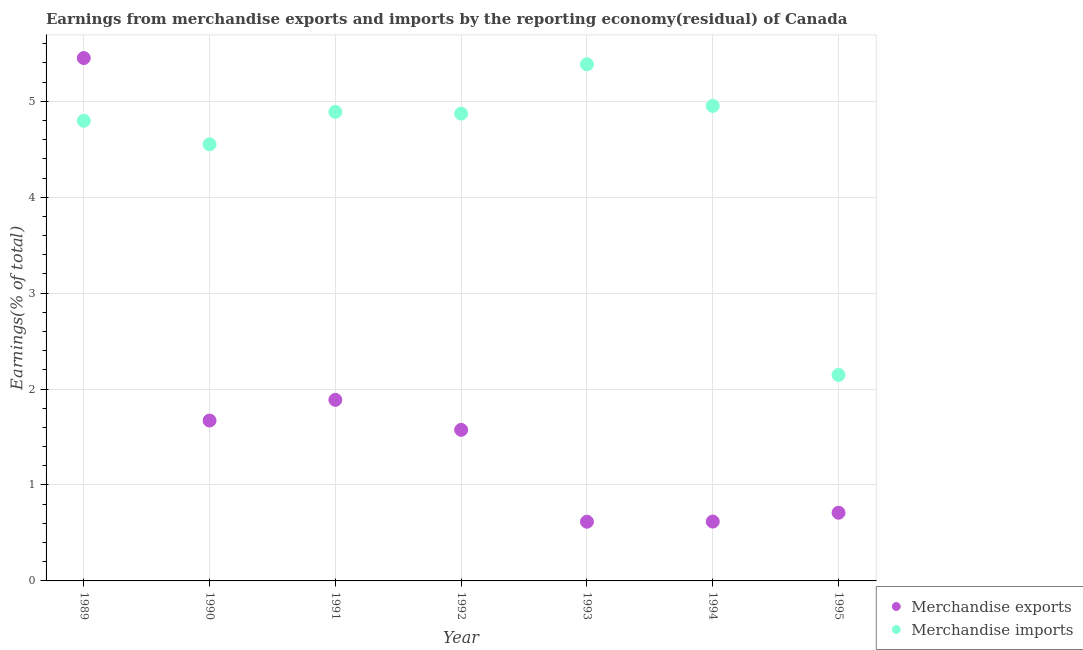How many different coloured dotlines are there?
Keep it short and to the point. 2. What is the earnings from merchandise exports in 1991?
Make the answer very short. 1.89. Across all years, what is the maximum earnings from merchandise exports?
Provide a short and direct response. 5.45. Across all years, what is the minimum earnings from merchandise imports?
Your response must be concise. 2.15. In which year was the earnings from merchandise imports maximum?
Provide a succinct answer. 1993. What is the total earnings from merchandise exports in the graph?
Ensure brevity in your answer.  12.53. What is the difference between the earnings from merchandise imports in 1991 and that in 1994?
Ensure brevity in your answer.  -0.06. What is the difference between the earnings from merchandise imports in 1990 and the earnings from merchandise exports in 1991?
Offer a very short reply. 2.66. What is the average earnings from merchandise exports per year?
Offer a very short reply. 1.79. In the year 1993, what is the difference between the earnings from merchandise imports and earnings from merchandise exports?
Your answer should be very brief. 4.77. What is the ratio of the earnings from merchandise exports in 1989 to that in 1990?
Give a very brief answer. 3.26. Is the earnings from merchandise imports in 1991 less than that in 1993?
Ensure brevity in your answer.  Yes. Is the difference between the earnings from merchandise exports in 1989 and 1995 greater than the difference between the earnings from merchandise imports in 1989 and 1995?
Provide a succinct answer. Yes. What is the difference between the highest and the second highest earnings from merchandise exports?
Ensure brevity in your answer.  3.56. What is the difference between the highest and the lowest earnings from merchandise imports?
Your answer should be compact. 3.24. Is the sum of the earnings from merchandise exports in 1992 and 1993 greater than the maximum earnings from merchandise imports across all years?
Provide a short and direct response. No. Is the earnings from merchandise exports strictly greater than the earnings from merchandise imports over the years?
Ensure brevity in your answer.  No. How many dotlines are there?
Provide a short and direct response. 2. What is the difference between two consecutive major ticks on the Y-axis?
Make the answer very short. 1. Are the values on the major ticks of Y-axis written in scientific E-notation?
Give a very brief answer. No. How many legend labels are there?
Offer a terse response. 2. What is the title of the graph?
Give a very brief answer. Earnings from merchandise exports and imports by the reporting economy(residual) of Canada. What is the label or title of the X-axis?
Offer a very short reply. Year. What is the label or title of the Y-axis?
Offer a terse response. Earnings(% of total). What is the Earnings(% of total) of Merchandise exports in 1989?
Keep it short and to the point. 5.45. What is the Earnings(% of total) in Merchandise imports in 1989?
Make the answer very short. 4.8. What is the Earnings(% of total) of Merchandise exports in 1990?
Your response must be concise. 1.67. What is the Earnings(% of total) in Merchandise imports in 1990?
Provide a succinct answer. 4.55. What is the Earnings(% of total) in Merchandise exports in 1991?
Offer a very short reply. 1.89. What is the Earnings(% of total) of Merchandise imports in 1991?
Offer a very short reply. 4.89. What is the Earnings(% of total) of Merchandise exports in 1992?
Your response must be concise. 1.57. What is the Earnings(% of total) of Merchandise imports in 1992?
Your answer should be very brief. 4.87. What is the Earnings(% of total) in Merchandise exports in 1993?
Your response must be concise. 0.62. What is the Earnings(% of total) of Merchandise imports in 1993?
Your answer should be very brief. 5.39. What is the Earnings(% of total) of Merchandise exports in 1994?
Provide a succinct answer. 0.62. What is the Earnings(% of total) in Merchandise imports in 1994?
Keep it short and to the point. 4.95. What is the Earnings(% of total) of Merchandise exports in 1995?
Your answer should be very brief. 0.71. What is the Earnings(% of total) in Merchandise imports in 1995?
Your answer should be compact. 2.15. Across all years, what is the maximum Earnings(% of total) in Merchandise exports?
Offer a very short reply. 5.45. Across all years, what is the maximum Earnings(% of total) of Merchandise imports?
Keep it short and to the point. 5.39. Across all years, what is the minimum Earnings(% of total) of Merchandise exports?
Offer a very short reply. 0.62. Across all years, what is the minimum Earnings(% of total) in Merchandise imports?
Provide a short and direct response. 2.15. What is the total Earnings(% of total) of Merchandise exports in the graph?
Give a very brief answer. 12.53. What is the total Earnings(% of total) in Merchandise imports in the graph?
Your answer should be compact. 31.59. What is the difference between the Earnings(% of total) of Merchandise exports in 1989 and that in 1990?
Provide a succinct answer. 3.78. What is the difference between the Earnings(% of total) of Merchandise imports in 1989 and that in 1990?
Make the answer very short. 0.25. What is the difference between the Earnings(% of total) in Merchandise exports in 1989 and that in 1991?
Give a very brief answer. 3.56. What is the difference between the Earnings(% of total) of Merchandise imports in 1989 and that in 1991?
Your answer should be compact. -0.09. What is the difference between the Earnings(% of total) in Merchandise exports in 1989 and that in 1992?
Offer a terse response. 3.88. What is the difference between the Earnings(% of total) of Merchandise imports in 1989 and that in 1992?
Offer a very short reply. -0.07. What is the difference between the Earnings(% of total) of Merchandise exports in 1989 and that in 1993?
Your response must be concise. 4.83. What is the difference between the Earnings(% of total) of Merchandise imports in 1989 and that in 1993?
Offer a terse response. -0.59. What is the difference between the Earnings(% of total) in Merchandise exports in 1989 and that in 1994?
Your response must be concise. 4.83. What is the difference between the Earnings(% of total) of Merchandise imports in 1989 and that in 1994?
Offer a terse response. -0.16. What is the difference between the Earnings(% of total) of Merchandise exports in 1989 and that in 1995?
Your answer should be very brief. 4.74. What is the difference between the Earnings(% of total) in Merchandise imports in 1989 and that in 1995?
Offer a terse response. 2.65. What is the difference between the Earnings(% of total) of Merchandise exports in 1990 and that in 1991?
Your answer should be compact. -0.22. What is the difference between the Earnings(% of total) of Merchandise imports in 1990 and that in 1991?
Your response must be concise. -0.34. What is the difference between the Earnings(% of total) in Merchandise exports in 1990 and that in 1992?
Keep it short and to the point. 0.1. What is the difference between the Earnings(% of total) in Merchandise imports in 1990 and that in 1992?
Provide a succinct answer. -0.32. What is the difference between the Earnings(% of total) of Merchandise exports in 1990 and that in 1993?
Your answer should be very brief. 1.05. What is the difference between the Earnings(% of total) of Merchandise imports in 1990 and that in 1993?
Your answer should be very brief. -0.83. What is the difference between the Earnings(% of total) in Merchandise exports in 1990 and that in 1994?
Offer a terse response. 1.05. What is the difference between the Earnings(% of total) of Merchandise imports in 1990 and that in 1994?
Your answer should be compact. -0.4. What is the difference between the Earnings(% of total) in Merchandise exports in 1990 and that in 1995?
Your answer should be compact. 0.96. What is the difference between the Earnings(% of total) in Merchandise imports in 1990 and that in 1995?
Your response must be concise. 2.4. What is the difference between the Earnings(% of total) in Merchandise exports in 1991 and that in 1992?
Offer a very short reply. 0.31. What is the difference between the Earnings(% of total) of Merchandise imports in 1991 and that in 1992?
Keep it short and to the point. 0.02. What is the difference between the Earnings(% of total) in Merchandise exports in 1991 and that in 1993?
Keep it short and to the point. 1.27. What is the difference between the Earnings(% of total) of Merchandise imports in 1991 and that in 1993?
Keep it short and to the point. -0.5. What is the difference between the Earnings(% of total) of Merchandise exports in 1991 and that in 1994?
Give a very brief answer. 1.27. What is the difference between the Earnings(% of total) of Merchandise imports in 1991 and that in 1994?
Your answer should be very brief. -0.06. What is the difference between the Earnings(% of total) in Merchandise exports in 1991 and that in 1995?
Give a very brief answer. 1.18. What is the difference between the Earnings(% of total) in Merchandise imports in 1991 and that in 1995?
Make the answer very short. 2.74. What is the difference between the Earnings(% of total) of Merchandise exports in 1992 and that in 1993?
Keep it short and to the point. 0.96. What is the difference between the Earnings(% of total) in Merchandise imports in 1992 and that in 1993?
Your answer should be very brief. -0.51. What is the difference between the Earnings(% of total) in Merchandise exports in 1992 and that in 1994?
Offer a very short reply. 0.96. What is the difference between the Earnings(% of total) of Merchandise imports in 1992 and that in 1994?
Keep it short and to the point. -0.08. What is the difference between the Earnings(% of total) in Merchandise exports in 1992 and that in 1995?
Give a very brief answer. 0.86. What is the difference between the Earnings(% of total) of Merchandise imports in 1992 and that in 1995?
Provide a short and direct response. 2.72. What is the difference between the Earnings(% of total) of Merchandise exports in 1993 and that in 1994?
Provide a succinct answer. -0. What is the difference between the Earnings(% of total) in Merchandise imports in 1993 and that in 1994?
Give a very brief answer. 0.43. What is the difference between the Earnings(% of total) in Merchandise exports in 1993 and that in 1995?
Your response must be concise. -0.09. What is the difference between the Earnings(% of total) in Merchandise imports in 1993 and that in 1995?
Provide a succinct answer. 3.24. What is the difference between the Earnings(% of total) of Merchandise exports in 1994 and that in 1995?
Your response must be concise. -0.09. What is the difference between the Earnings(% of total) of Merchandise imports in 1994 and that in 1995?
Your answer should be very brief. 2.8. What is the difference between the Earnings(% of total) in Merchandise exports in 1989 and the Earnings(% of total) in Merchandise imports in 1990?
Your answer should be compact. 0.9. What is the difference between the Earnings(% of total) of Merchandise exports in 1989 and the Earnings(% of total) of Merchandise imports in 1991?
Offer a terse response. 0.56. What is the difference between the Earnings(% of total) of Merchandise exports in 1989 and the Earnings(% of total) of Merchandise imports in 1992?
Provide a short and direct response. 0.58. What is the difference between the Earnings(% of total) in Merchandise exports in 1989 and the Earnings(% of total) in Merchandise imports in 1993?
Your answer should be very brief. 0.06. What is the difference between the Earnings(% of total) of Merchandise exports in 1989 and the Earnings(% of total) of Merchandise imports in 1994?
Ensure brevity in your answer.  0.5. What is the difference between the Earnings(% of total) in Merchandise exports in 1989 and the Earnings(% of total) in Merchandise imports in 1995?
Your response must be concise. 3.3. What is the difference between the Earnings(% of total) of Merchandise exports in 1990 and the Earnings(% of total) of Merchandise imports in 1991?
Make the answer very short. -3.22. What is the difference between the Earnings(% of total) in Merchandise exports in 1990 and the Earnings(% of total) in Merchandise imports in 1992?
Your response must be concise. -3.2. What is the difference between the Earnings(% of total) of Merchandise exports in 1990 and the Earnings(% of total) of Merchandise imports in 1993?
Provide a short and direct response. -3.71. What is the difference between the Earnings(% of total) of Merchandise exports in 1990 and the Earnings(% of total) of Merchandise imports in 1994?
Provide a short and direct response. -3.28. What is the difference between the Earnings(% of total) of Merchandise exports in 1990 and the Earnings(% of total) of Merchandise imports in 1995?
Provide a short and direct response. -0.48. What is the difference between the Earnings(% of total) of Merchandise exports in 1991 and the Earnings(% of total) of Merchandise imports in 1992?
Your answer should be very brief. -2.98. What is the difference between the Earnings(% of total) of Merchandise exports in 1991 and the Earnings(% of total) of Merchandise imports in 1993?
Provide a succinct answer. -3.5. What is the difference between the Earnings(% of total) of Merchandise exports in 1991 and the Earnings(% of total) of Merchandise imports in 1994?
Your answer should be very brief. -3.06. What is the difference between the Earnings(% of total) of Merchandise exports in 1991 and the Earnings(% of total) of Merchandise imports in 1995?
Your answer should be very brief. -0.26. What is the difference between the Earnings(% of total) of Merchandise exports in 1992 and the Earnings(% of total) of Merchandise imports in 1993?
Your answer should be compact. -3.81. What is the difference between the Earnings(% of total) in Merchandise exports in 1992 and the Earnings(% of total) in Merchandise imports in 1994?
Provide a short and direct response. -3.38. What is the difference between the Earnings(% of total) of Merchandise exports in 1992 and the Earnings(% of total) of Merchandise imports in 1995?
Give a very brief answer. -0.57. What is the difference between the Earnings(% of total) in Merchandise exports in 1993 and the Earnings(% of total) in Merchandise imports in 1994?
Your answer should be very brief. -4.33. What is the difference between the Earnings(% of total) in Merchandise exports in 1993 and the Earnings(% of total) in Merchandise imports in 1995?
Your answer should be compact. -1.53. What is the difference between the Earnings(% of total) of Merchandise exports in 1994 and the Earnings(% of total) of Merchandise imports in 1995?
Your response must be concise. -1.53. What is the average Earnings(% of total) in Merchandise exports per year?
Your response must be concise. 1.79. What is the average Earnings(% of total) in Merchandise imports per year?
Give a very brief answer. 4.51. In the year 1989, what is the difference between the Earnings(% of total) of Merchandise exports and Earnings(% of total) of Merchandise imports?
Give a very brief answer. 0.65. In the year 1990, what is the difference between the Earnings(% of total) in Merchandise exports and Earnings(% of total) in Merchandise imports?
Ensure brevity in your answer.  -2.88. In the year 1991, what is the difference between the Earnings(% of total) of Merchandise exports and Earnings(% of total) of Merchandise imports?
Offer a terse response. -3. In the year 1992, what is the difference between the Earnings(% of total) of Merchandise exports and Earnings(% of total) of Merchandise imports?
Make the answer very short. -3.3. In the year 1993, what is the difference between the Earnings(% of total) in Merchandise exports and Earnings(% of total) in Merchandise imports?
Make the answer very short. -4.77. In the year 1994, what is the difference between the Earnings(% of total) of Merchandise exports and Earnings(% of total) of Merchandise imports?
Provide a short and direct response. -4.33. In the year 1995, what is the difference between the Earnings(% of total) of Merchandise exports and Earnings(% of total) of Merchandise imports?
Provide a succinct answer. -1.44. What is the ratio of the Earnings(% of total) of Merchandise exports in 1989 to that in 1990?
Make the answer very short. 3.26. What is the ratio of the Earnings(% of total) in Merchandise imports in 1989 to that in 1990?
Your response must be concise. 1.05. What is the ratio of the Earnings(% of total) in Merchandise exports in 1989 to that in 1991?
Your answer should be very brief. 2.89. What is the ratio of the Earnings(% of total) of Merchandise imports in 1989 to that in 1991?
Keep it short and to the point. 0.98. What is the ratio of the Earnings(% of total) in Merchandise exports in 1989 to that in 1992?
Make the answer very short. 3.46. What is the ratio of the Earnings(% of total) of Merchandise imports in 1989 to that in 1992?
Give a very brief answer. 0.98. What is the ratio of the Earnings(% of total) of Merchandise exports in 1989 to that in 1993?
Keep it short and to the point. 8.83. What is the ratio of the Earnings(% of total) of Merchandise imports in 1989 to that in 1993?
Ensure brevity in your answer.  0.89. What is the ratio of the Earnings(% of total) of Merchandise exports in 1989 to that in 1994?
Your answer should be compact. 8.81. What is the ratio of the Earnings(% of total) in Merchandise imports in 1989 to that in 1994?
Give a very brief answer. 0.97. What is the ratio of the Earnings(% of total) in Merchandise exports in 1989 to that in 1995?
Ensure brevity in your answer.  7.67. What is the ratio of the Earnings(% of total) of Merchandise imports in 1989 to that in 1995?
Ensure brevity in your answer.  2.23. What is the ratio of the Earnings(% of total) in Merchandise exports in 1990 to that in 1991?
Give a very brief answer. 0.89. What is the ratio of the Earnings(% of total) of Merchandise imports in 1990 to that in 1991?
Your answer should be very brief. 0.93. What is the ratio of the Earnings(% of total) of Merchandise exports in 1990 to that in 1992?
Offer a terse response. 1.06. What is the ratio of the Earnings(% of total) of Merchandise imports in 1990 to that in 1992?
Your answer should be compact. 0.93. What is the ratio of the Earnings(% of total) in Merchandise exports in 1990 to that in 1993?
Your answer should be compact. 2.71. What is the ratio of the Earnings(% of total) of Merchandise imports in 1990 to that in 1993?
Ensure brevity in your answer.  0.84. What is the ratio of the Earnings(% of total) in Merchandise exports in 1990 to that in 1994?
Ensure brevity in your answer.  2.7. What is the ratio of the Earnings(% of total) of Merchandise imports in 1990 to that in 1994?
Give a very brief answer. 0.92. What is the ratio of the Earnings(% of total) in Merchandise exports in 1990 to that in 1995?
Your answer should be compact. 2.35. What is the ratio of the Earnings(% of total) in Merchandise imports in 1990 to that in 1995?
Make the answer very short. 2.12. What is the ratio of the Earnings(% of total) of Merchandise exports in 1991 to that in 1992?
Your answer should be compact. 1.2. What is the ratio of the Earnings(% of total) in Merchandise exports in 1991 to that in 1993?
Your answer should be very brief. 3.06. What is the ratio of the Earnings(% of total) in Merchandise imports in 1991 to that in 1993?
Make the answer very short. 0.91. What is the ratio of the Earnings(% of total) of Merchandise exports in 1991 to that in 1994?
Give a very brief answer. 3.05. What is the ratio of the Earnings(% of total) in Merchandise imports in 1991 to that in 1994?
Your response must be concise. 0.99. What is the ratio of the Earnings(% of total) in Merchandise exports in 1991 to that in 1995?
Offer a very short reply. 2.66. What is the ratio of the Earnings(% of total) of Merchandise imports in 1991 to that in 1995?
Keep it short and to the point. 2.28. What is the ratio of the Earnings(% of total) in Merchandise exports in 1992 to that in 1993?
Your response must be concise. 2.55. What is the ratio of the Earnings(% of total) in Merchandise imports in 1992 to that in 1993?
Make the answer very short. 0.9. What is the ratio of the Earnings(% of total) of Merchandise exports in 1992 to that in 1994?
Provide a succinct answer. 2.55. What is the ratio of the Earnings(% of total) in Merchandise imports in 1992 to that in 1994?
Your response must be concise. 0.98. What is the ratio of the Earnings(% of total) in Merchandise exports in 1992 to that in 1995?
Offer a terse response. 2.22. What is the ratio of the Earnings(% of total) in Merchandise imports in 1992 to that in 1995?
Your answer should be very brief. 2.27. What is the ratio of the Earnings(% of total) in Merchandise exports in 1993 to that in 1994?
Ensure brevity in your answer.  1. What is the ratio of the Earnings(% of total) of Merchandise imports in 1993 to that in 1994?
Provide a succinct answer. 1.09. What is the ratio of the Earnings(% of total) of Merchandise exports in 1993 to that in 1995?
Offer a very short reply. 0.87. What is the ratio of the Earnings(% of total) of Merchandise imports in 1993 to that in 1995?
Offer a terse response. 2.51. What is the ratio of the Earnings(% of total) of Merchandise exports in 1994 to that in 1995?
Keep it short and to the point. 0.87. What is the ratio of the Earnings(% of total) of Merchandise imports in 1994 to that in 1995?
Offer a very short reply. 2.31. What is the difference between the highest and the second highest Earnings(% of total) in Merchandise exports?
Give a very brief answer. 3.56. What is the difference between the highest and the second highest Earnings(% of total) of Merchandise imports?
Provide a short and direct response. 0.43. What is the difference between the highest and the lowest Earnings(% of total) of Merchandise exports?
Provide a succinct answer. 4.83. What is the difference between the highest and the lowest Earnings(% of total) of Merchandise imports?
Provide a short and direct response. 3.24. 